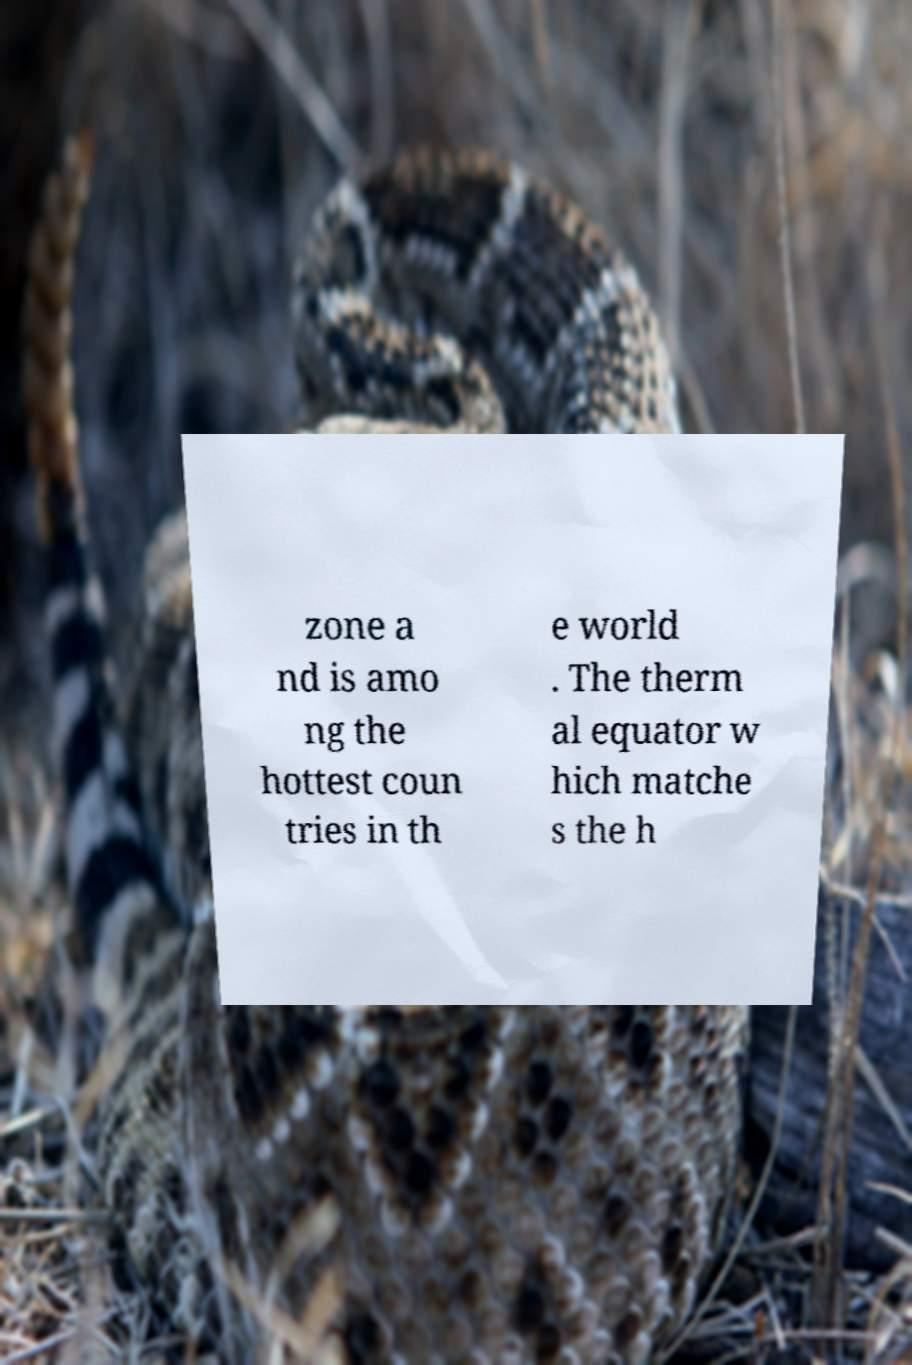Could you assist in decoding the text presented in this image and type it out clearly? zone a nd is amo ng the hottest coun tries in th e world . The therm al equator w hich matche s the h 